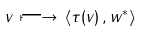Convert formula to latex. <formula><loc_0><loc_0><loc_500><loc_500>v \, \longmapsto \, \langle \tau ( v ) \, , w ^ { * } \rangle</formula> 